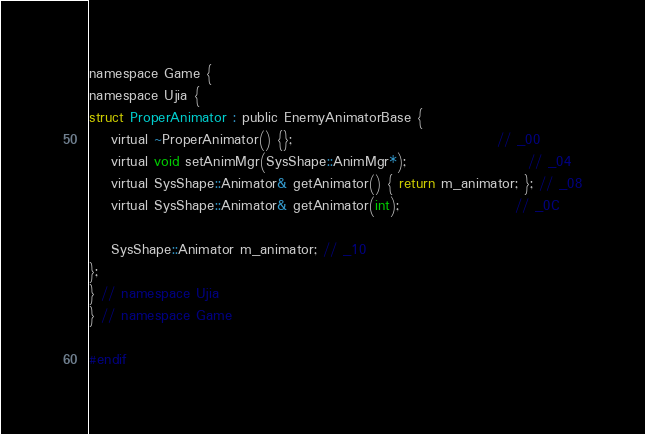Convert code to text. <code><loc_0><loc_0><loc_500><loc_500><_C_>
namespace Game {
namespace Ujia {
struct ProperAnimator : public EnemyAnimatorBase {
	virtual ~ProperAnimator() {};                                     // _00
	virtual void setAnimMgr(SysShape::AnimMgr*);                      // _04
	virtual SysShape::Animator& getAnimator() { return m_animator; }; // _08
	virtual SysShape::Animator& getAnimator(int);                     // _0C

	SysShape::Animator m_animator; // _10
};
} // namespace Ujia
} // namespace Game

#endif
</code> 